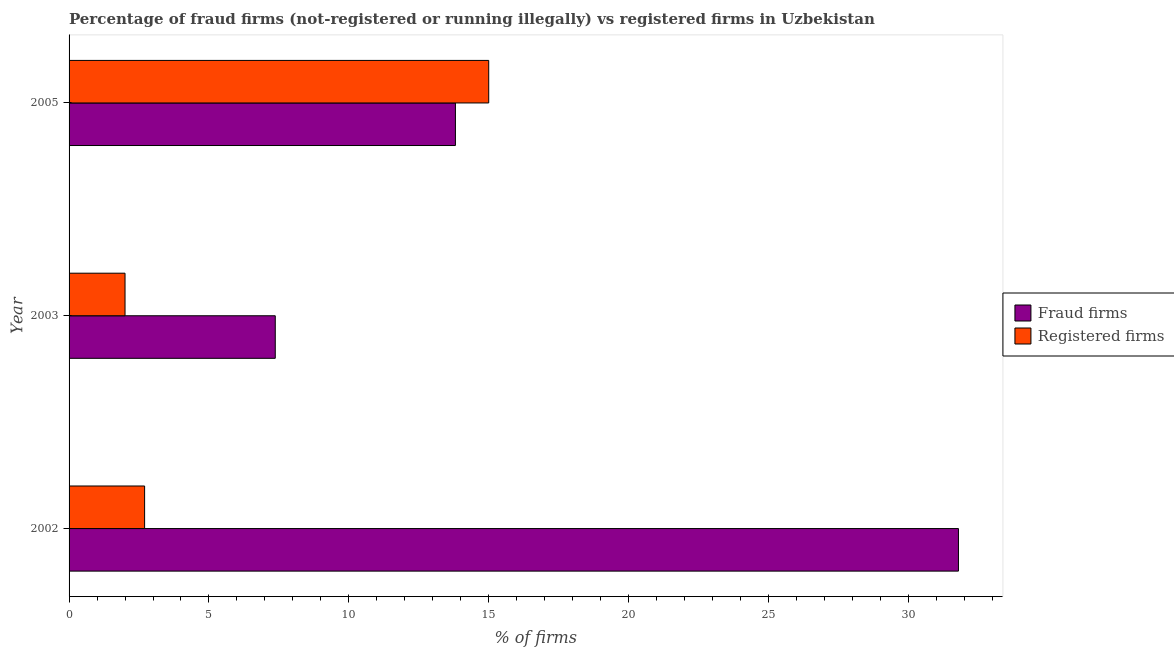How many groups of bars are there?
Your answer should be compact. 3. Are the number of bars per tick equal to the number of legend labels?
Provide a succinct answer. Yes. Are the number of bars on each tick of the Y-axis equal?
Your answer should be compact. Yes. Across all years, what is the maximum percentage of fraud firms?
Keep it short and to the point. 31.79. In which year was the percentage of fraud firms maximum?
Make the answer very short. 2002. What is the total percentage of fraud firms in the graph?
Offer a terse response. 52.97. What is the difference between the percentage of fraud firms in 2002 and that in 2003?
Your answer should be very brief. 24.42. What is the difference between the percentage of registered firms in 2002 and the percentage of fraud firms in 2003?
Provide a short and direct response. -4.67. What is the average percentage of registered firms per year?
Provide a succinct answer. 6.57. In the year 2002, what is the difference between the percentage of fraud firms and percentage of registered firms?
Ensure brevity in your answer.  29.09. In how many years, is the percentage of fraud firms greater than 18 %?
Your answer should be compact. 1. What is the ratio of the percentage of fraud firms in 2003 to that in 2005?
Make the answer very short. 0.53. Is the difference between the percentage of fraud firms in 2002 and 2003 greater than the difference between the percentage of registered firms in 2002 and 2003?
Your response must be concise. Yes. What is the difference between the highest and the lowest percentage of registered firms?
Ensure brevity in your answer.  13. In how many years, is the percentage of registered firms greater than the average percentage of registered firms taken over all years?
Your answer should be compact. 1. What does the 1st bar from the top in 2005 represents?
Ensure brevity in your answer.  Registered firms. What does the 2nd bar from the bottom in 2003 represents?
Give a very brief answer. Registered firms. How many bars are there?
Your response must be concise. 6. Are all the bars in the graph horizontal?
Give a very brief answer. Yes. What is the difference between two consecutive major ticks on the X-axis?
Your answer should be compact. 5. Are the values on the major ticks of X-axis written in scientific E-notation?
Your answer should be very brief. No. Does the graph contain any zero values?
Make the answer very short. No. How many legend labels are there?
Offer a terse response. 2. What is the title of the graph?
Your answer should be compact. Percentage of fraud firms (not-registered or running illegally) vs registered firms in Uzbekistan. What is the label or title of the X-axis?
Your response must be concise. % of firms. What is the % of firms of Fraud firms in 2002?
Offer a terse response. 31.79. What is the % of firms in Registered firms in 2002?
Offer a terse response. 2.7. What is the % of firms in Fraud firms in 2003?
Give a very brief answer. 7.37. What is the % of firms in Registered firms in 2003?
Ensure brevity in your answer.  2. What is the % of firms of Fraud firms in 2005?
Provide a succinct answer. 13.81. What is the % of firms of Registered firms in 2005?
Your response must be concise. 15. Across all years, what is the maximum % of firms of Fraud firms?
Provide a succinct answer. 31.79. Across all years, what is the minimum % of firms in Fraud firms?
Give a very brief answer. 7.37. What is the total % of firms of Fraud firms in the graph?
Offer a very short reply. 52.97. What is the total % of firms of Registered firms in the graph?
Offer a terse response. 19.7. What is the difference between the % of firms in Fraud firms in 2002 and that in 2003?
Provide a succinct answer. 24.42. What is the difference between the % of firms in Registered firms in 2002 and that in 2003?
Keep it short and to the point. 0.7. What is the difference between the % of firms of Fraud firms in 2002 and that in 2005?
Your answer should be very brief. 17.98. What is the difference between the % of firms in Fraud firms in 2003 and that in 2005?
Ensure brevity in your answer.  -6.44. What is the difference between the % of firms in Registered firms in 2003 and that in 2005?
Ensure brevity in your answer.  -13. What is the difference between the % of firms of Fraud firms in 2002 and the % of firms of Registered firms in 2003?
Provide a short and direct response. 29.79. What is the difference between the % of firms of Fraud firms in 2002 and the % of firms of Registered firms in 2005?
Give a very brief answer. 16.79. What is the difference between the % of firms of Fraud firms in 2003 and the % of firms of Registered firms in 2005?
Offer a terse response. -7.63. What is the average % of firms in Fraud firms per year?
Give a very brief answer. 17.66. What is the average % of firms in Registered firms per year?
Your answer should be compact. 6.57. In the year 2002, what is the difference between the % of firms in Fraud firms and % of firms in Registered firms?
Give a very brief answer. 29.09. In the year 2003, what is the difference between the % of firms of Fraud firms and % of firms of Registered firms?
Offer a terse response. 5.37. In the year 2005, what is the difference between the % of firms in Fraud firms and % of firms in Registered firms?
Keep it short and to the point. -1.19. What is the ratio of the % of firms of Fraud firms in 2002 to that in 2003?
Make the answer very short. 4.31. What is the ratio of the % of firms of Registered firms in 2002 to that in 2003?
Provide a short and direct response. 1.35. What is the ratio of the % of firms of Fraud firms in 2002 to that in 2005?
Provide a short and direct response. 2.3. What is the ratio of the % of firms in Registered firms in 2002 to that in 2005?
Your answer should be very brief. 0.18. What is the ratio of the % of firms of Fraud firms in 2003 to that in 2005?
Your answer should be very brief. 0.53. What is the ratio of the % of firms in Registered firms in 2003 to that in 2005?
Give a very brief answer. 0.13. What is the difference between the highest and the second highest % of firms in Fraud firms?
Offer a very short reply. 17.98. What is the difference between the highest and the second highest % of firms of Registered firms?
Make the answer very short. 12.3. What is the difference between the highest and the lowest % of firms in Fraud firms?
Your answer should be compact. 24.42. What is the difference between the highest and the lowest % of firms in Registered firms?
Keep it short and to the point. 13. 